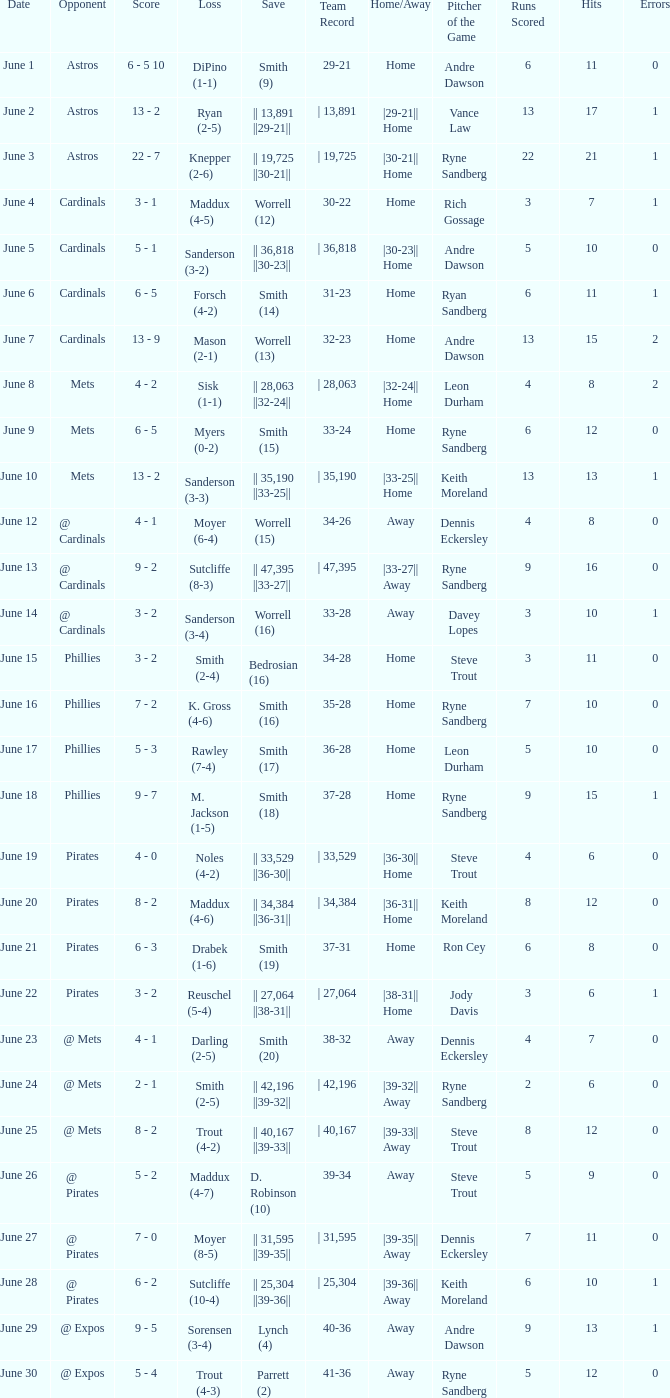What is the date for the contest that featured a loss of sutcliffe (10-4)? June 28. 